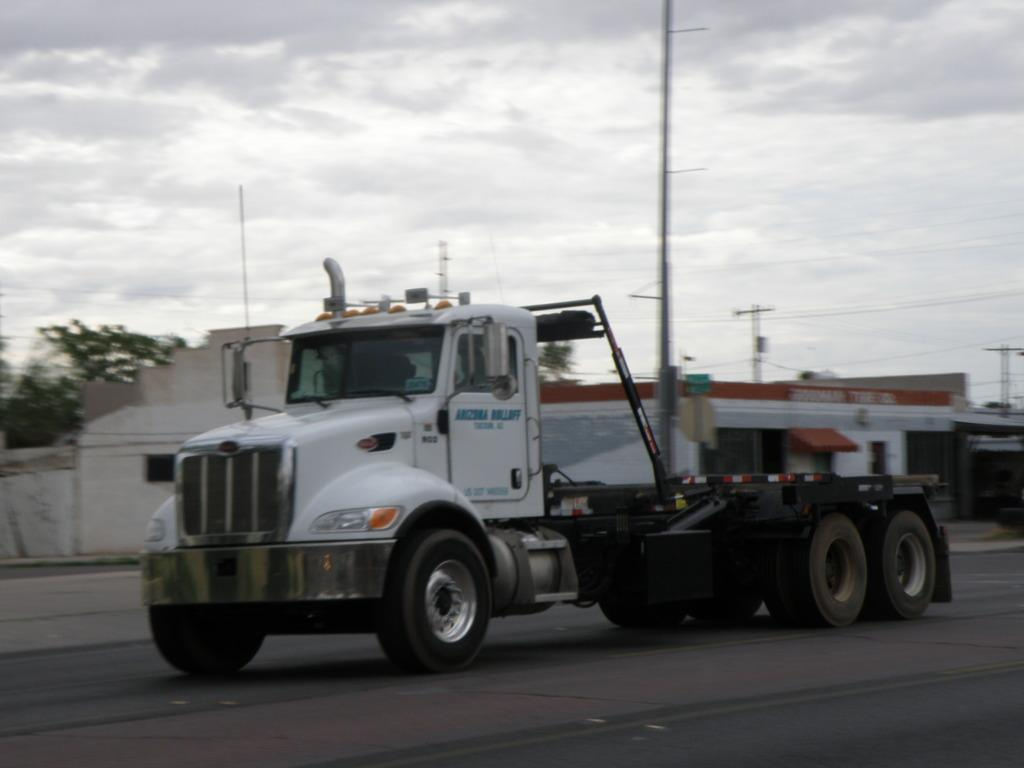What is the main subject of the image? The main subject of the image is a vehicle moving on the road. What can be seen in the background of the image? There are buildings, poles, and trees in the background of the image. How would you describe the sky in the image? The sky is cloudy in the image. What type of milk is being poured into the train in the image? There is no train or milk present in the image; it features a vehicle moving on the road with a cloudy sky in the background. 